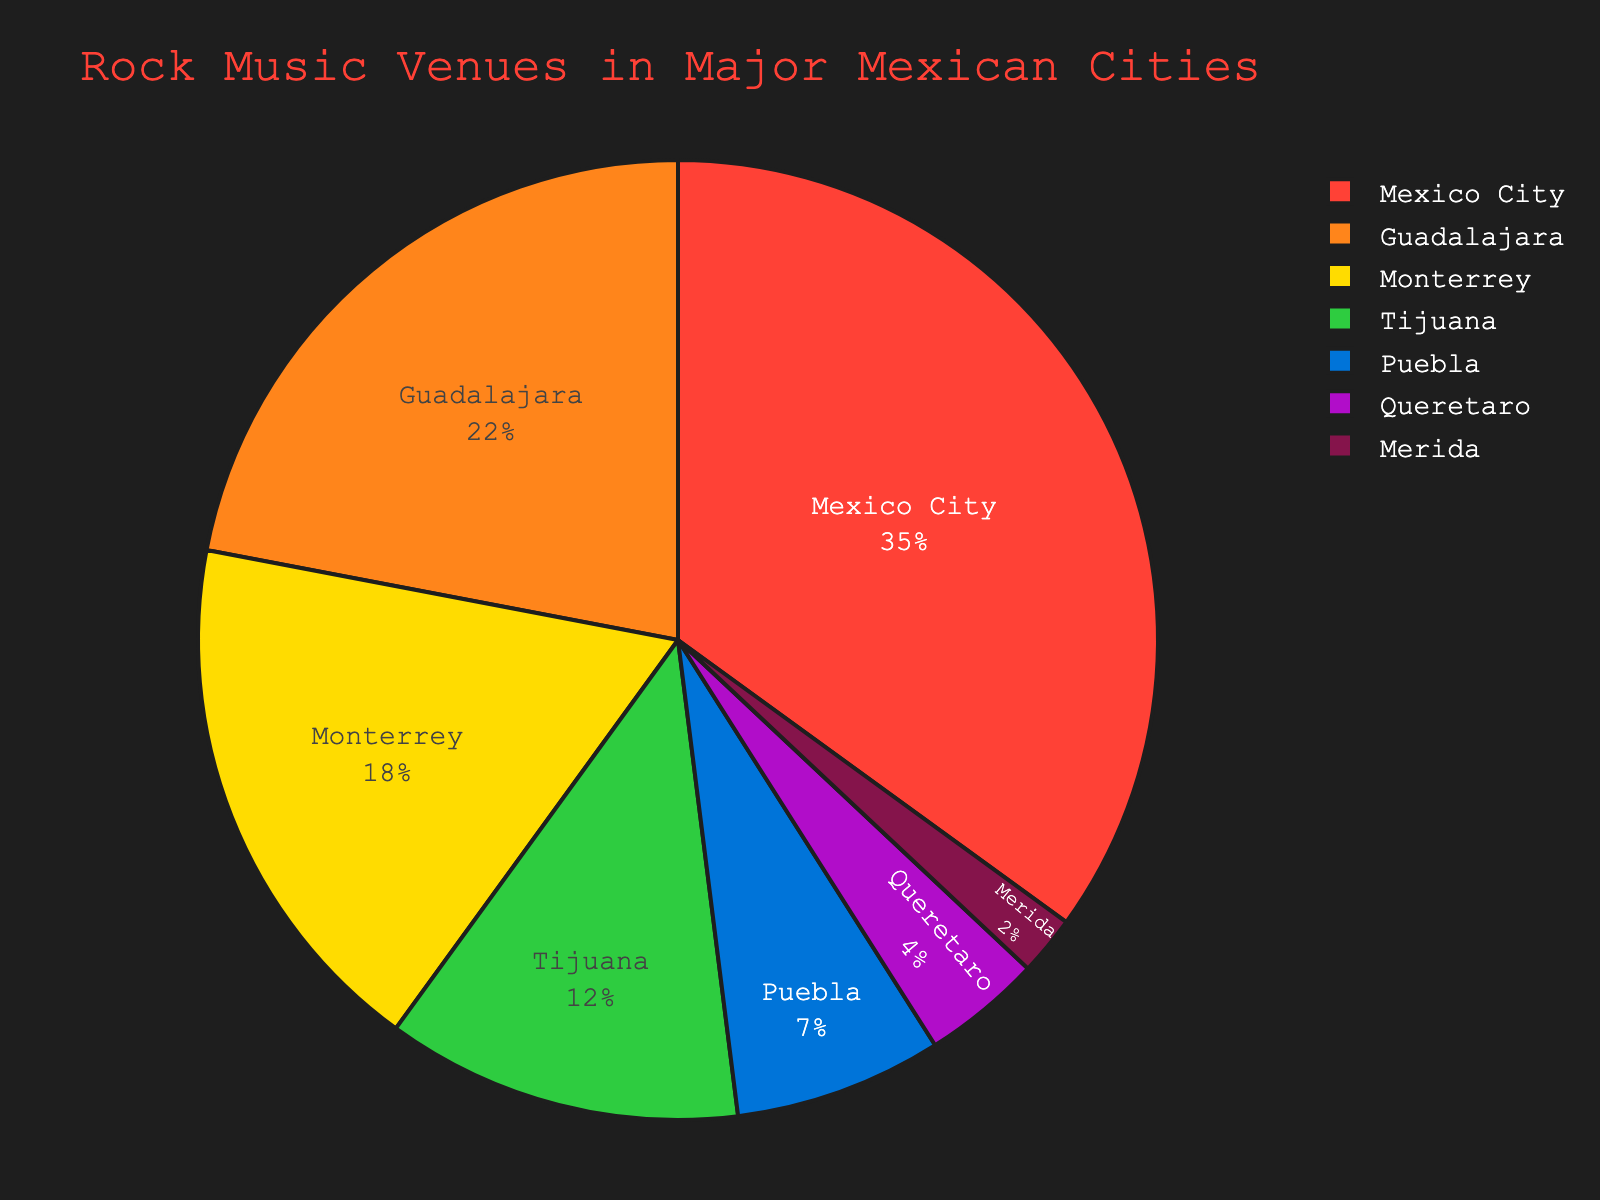What's the percentage of rock music venues in Mexico City? By referring directly to the figure, we can see that Mexico City has the largest portion of the pie chart. The label shows Mexico City - 35%.
Answer: 35% Which city has the second highest percentage of rock music venues? Observing the figure, Guadalajara has the second largest slice with a label indicating 22%.
Answer: Guadalajara How much greater is the percentage of venues in Monterrey compared to Merida? The figure shows Monterrey with 18% and Merida with 2%. The difference is calculated as 18% - 2% = 16%.
Answer: 16% What is the combined percentage of rock music venues in Puebla and Tijuana? Combining the percentages for Puebla (7%) and Tijuana (12%) gives 7% + 12% = 19%.
Answer: 19% Which city has the least percentage of rock music venues? Observing the labels in the chart, Merida has the smallest slice labeled 2%.
Answer: Merida By how much does Mexico City's percentage exceed that of Queretaro? Mexico City has 35% while Queretaro has 4%. The difference is 35% - 4% = 31%.
Answer: 31% What is the visual color associated with Tijuana’s slice of the pie? Checking the corresponding slice for Tijuana, it is represented in a green color.
Answer: green Is the percentage of rock venues in Guadalajara greater than the combined percentages of Queretaro and Merida? Guadalajara has 22%, while Queretaro and Merida have 4% and 2% respectively. The combined percentage for Queretaro and Merida is 4% + 2% = 6%, which is less than 22%.
Answer: Yes What is the aggregate percentage of rock venues for the top three cities? The top three cities are Mexico City (35%), Guadalajara (22%), and Monterrey (18%). Summing these gives 35% + 22% + 18% = 75%.
Answer: 75% Which city has a percentage that is closest to 10%? Comparing the values, Tijuana with 12% is closest to 10%.
Answer: Tijuana 